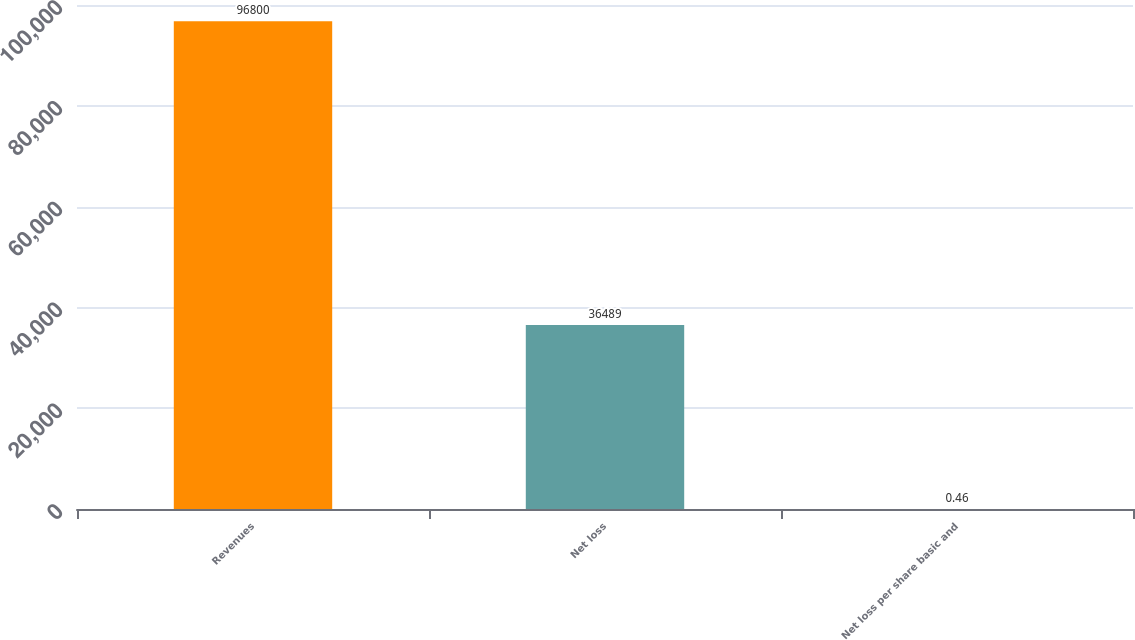<chart> <loc_0><loc_0><loc_500><loc_500><bar_chart><fcel>Revenues<fcel>Net loss<fcel>Net loss per share basic and<nl><fcel>96800<fcel>36489<fcel>0.46<nl></chart> 